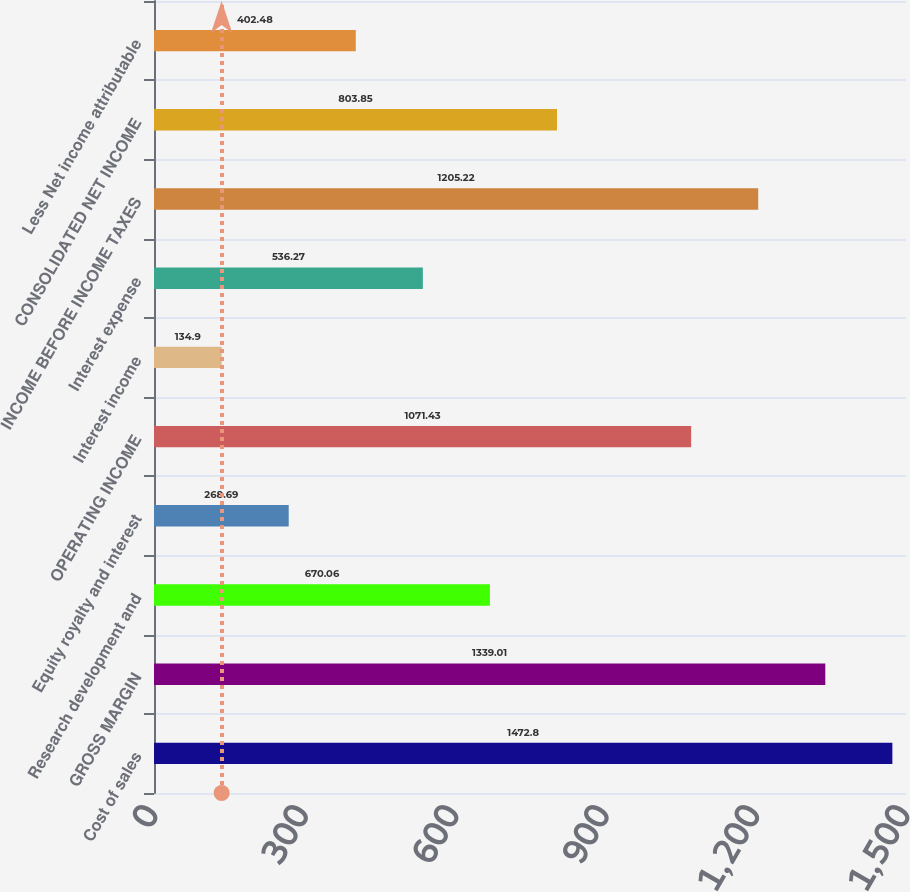Convert chart to OTSL. <chart><loc_0><loc_0><loc_500><loc_500><bar_chart><fcel>Cost of sales<fcel>GROSS MARGIN<fcel>Research development and<fcel>Equity royalty and interest<fcel>OPERATING INCOME<fcel>Interest income<fcel>Interest expense<fcel>INCOME BEFORE INCOME TAXES<fcel>CONSOLIDATED NET INCOME<fcel>Less Net income attributable<nl><fcel>1472.8<fcel>1339.01<fcel>670.06<fcel>268.69<fcel>1071.43<fcel>134.9<fcel>536.27<fcel>1205.22<fcel>803.85<fcel>402.48<nl></chart> 